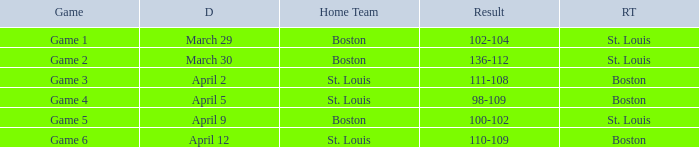Could you parse the entire table? {'header': ['Game', 'D', 'Home Team', 'Result', 'RT'], 'rows': [['Game 1', 'March 29', 'Boston', '102-104', 'St. Louis'], ['Game 2', 'March 30', 'Boston', '136-112', 'St. Louis'], ['Game 3', 'April 2', 'St. Louis', '111-108', 'Boston'], ['Game 4', 'April 5', 'St. Louis', '98-109', 'Boston'], ['Game 5', 'April 9', 'Boston', '100-102', 'St. Louis'], ['Game 6', 'April 12', 'St. Louis', '110-109', 'Boston']]} What is the Game number on April 12 with St. Louis Home Team? Game 6. 